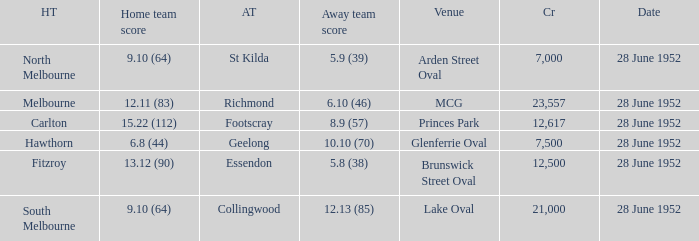What is the away team when north melbourne is at home? St Kilda. 